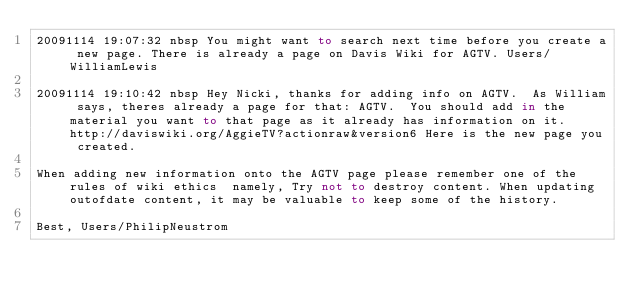<code> <loc_0><loc_0><loc_500><loc_500><_FORTRAN_>20091114 19:07:32 nbsp You might want to search next time before you create a new page. There is already a page on Davis Wiki for AGTV. Users/WilliamLewis

20091114 19:10:42 nbsp Hey Nicki, thanks for adding info on AGTV.  As William says, theres already a page for that: AGTV.  You should add in the material you want to that page as it already has information on it.  http://daviswiki.org/AggieTV?actionraw&version6 Here is the new page you created.

When adding new information onto the AGTV page please remember one of the rules of wiki ethics  namely, Try not to destroy content. When updating outofdate content, it may be valuable to keep some of the history.

Best, Users/PhilipNeustrom
</code> 